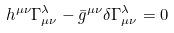<formula> <loc_0><loc_0><loc_500><loc_500>h ^ { \mu \nu } \Gamma _ { \mu \nu } ^ { \lambda } - \bar { g } ^ { \mu \nu } \delta \Gamma _ { \mu \nu } ^ { \lambda } = 0</formula> 